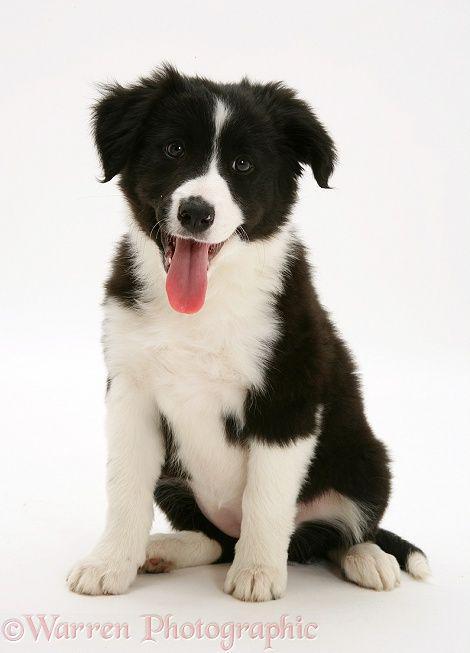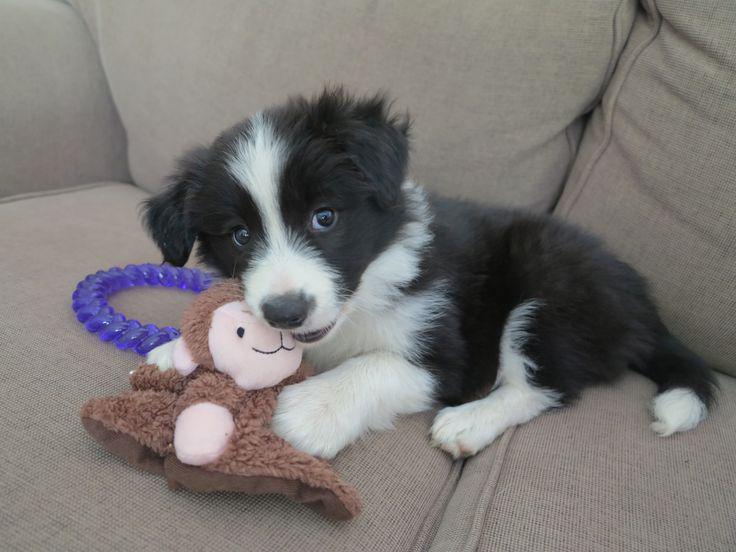The first image is the image on the left, the second image is the image on the right. For the images displayed, is the sentence "There are four puppies in the pair of images." factually correct? Answer yes or no. No. The first image is the image on the left, the second image is the image on the right. For the images displayed, is the sentence "Both images contain only one dog." factually correct? Answer yes or no. Yes. 